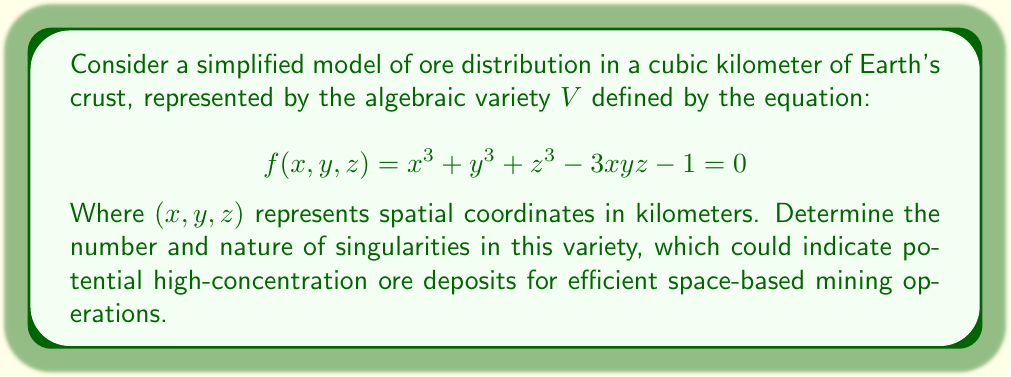Can you answer this question? To analyze the singularities of the variety $V$, we need to follow these steps:

1) Find the partial derivatives of $f(x,y,z)$:
   $$\frac{\partial f}{\partial x} = 3x^2 - 3yz$$
   $$\frac{\partial f}{\partial y} = 3y^2 - 3xz$$
   $$\frac{\partial f}{\partial z} = 3z^2 - 3xy$$

2) Singularities occur where all partial derivatives and $f$ itself are simultaneously zero. So we need to solve the system:
   $$\begin{cases}
   3x^2 - 3yz = 0 \\
   3y^2 - 3xz = 0 \\
   3z^2 - 3xy = 0 \\
   x^3 + y^3 + z^3 - 3xyz - 1 = 0
   \end{cases}$$

3) From the first three equations, we can deduce:
   $$x^2 = yz, \quad y^2 = xz, \quad z^2 = xy$$

4) Multiplying these equations:
   $$x^2y^2z^2 = y^2z^2 \cdot x^2z^2 \cdot x^2y^2$$
   $$(xyz)^2 = (xyz)^3$$

5) This implies either $xyz = 0$ or $xyz = 1$. However, $xyz = 0$ doesn't satisfy the original equation, so we must have $xyz = 1$.

6) Substituting this back into the original equation:
   $$x^3 + y^3 + z^3 - 3(1) - 1 = 0$$
   $$x^3 + y^3 + z^3 = 4$$

7) Given the symmetry of the equations, we can deduce that $x = y = z = \sqrt[3]{1} = 1$.

8) Therefore, there is only one singularity at the point $(1,1,1)$.

This singularity represents a potential high-concentration ore deposit that could be targeted for efficient space-based mining operations.
Answer: One singularity at (1,1,1) 